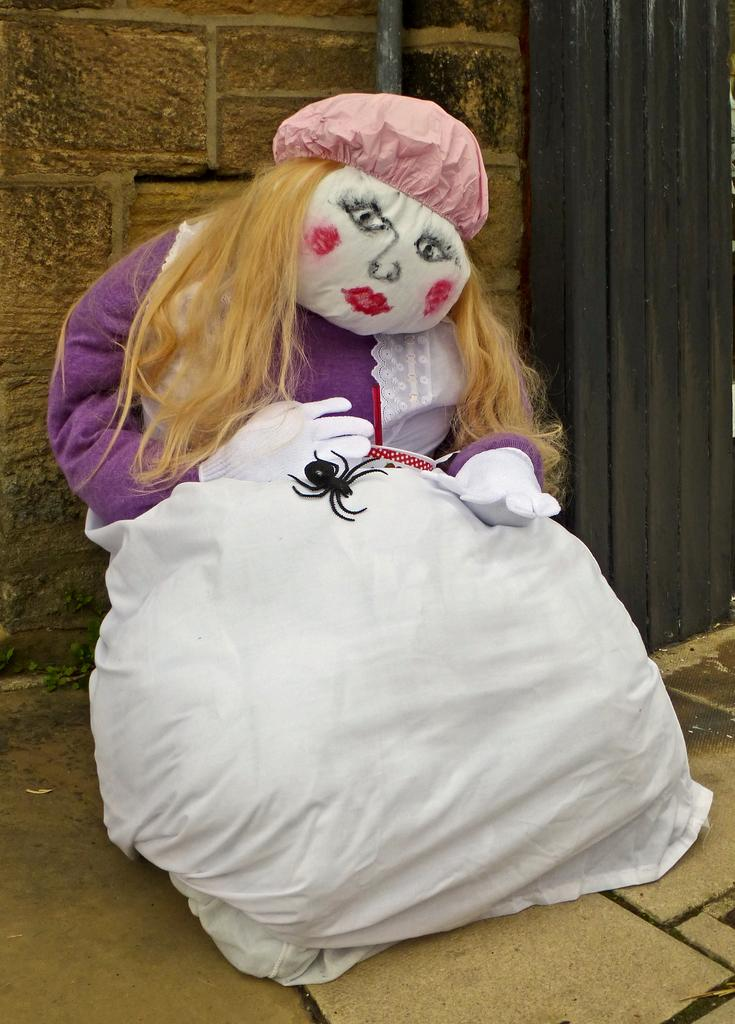What object is present in the image that resembles a toy? There is a toy in the image. What accessories is the toy wearing? The toy is wearing a hat and gloves. What type of creature is on the toy? There is a spider on the toy. What can be seen in the background of the image? There is a brick wall in the background of the image. What songs is the toy singing in the image? The toy is not singing in the image; it is a toy and does not have the ability to sing. 